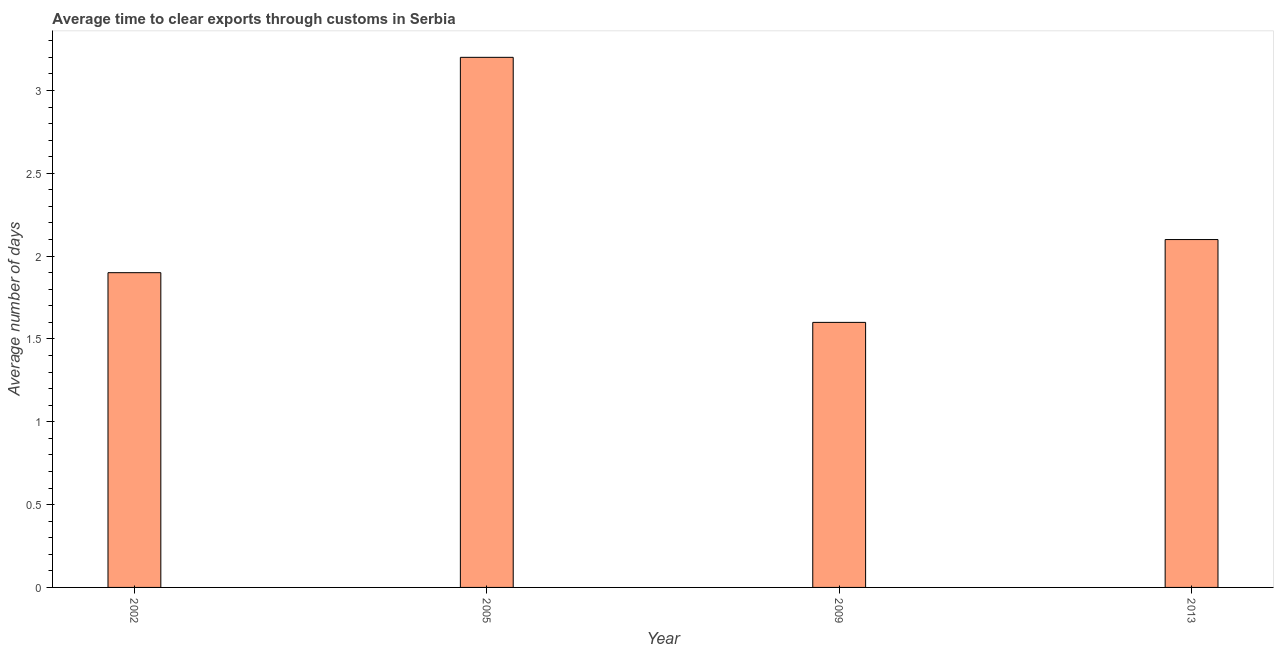Does the graph contain any zero values?
Give a very brief answer. No. Does the graph contain grids?
Provide a short and direct response. No. What is the title of the graph?
Your response must be concise. Average time to clear exports through customs in Serbia. What is the label or title of the Y-axis?
Keep it short and to the point. Average number of days. Across all years, what is the maximum time to clear exports through customs?
Provide a short and direct response. 3.2. Across all years, what is the minimum time to clear exports through customs?
Provide a short and direct response. 1.6. In which year was the time to clear exports through customs minimum?
Keep it short and to the point. 2009. What is the sum of the time to clear exports through customs?
Make the answer very short. 8.8. In how many years, is the time to clear exports through customs greater than 0.1 days?
Your answer should be very brief. 4. What is the ratio of the time to clear exports through customs in 2002 to that in 2005?
Your answer should be compact. 0.59. Is the time to clear exports through customs in 2002 less than that in 2013?
Make the answer very short. Yes. Is the sum of the time to clear exports through customs in 2005 and 2013 greater than the maximum time to clear exports through customs across all years?
Give a very brief answer. Yes. In how many years, is the time to clear exports through customs greater than the average time to clear exports through customs taken over all years?
Your response must be concise. 1. How many years are there in the graph?
Keep it short and to the point. 4. What is the difference between two consecutive major ticks on the Y-axis?
Your response must be concise. 0.5. What is the Average number of days of 2002?
Ensure brevity in your answer.  1.9. What is the Average number of days in 2005?
Ensure brevity in your answer.  3.2. What is the Average number of days of 2009?
Provide a short and direct response. 1.6. What is the difference between the Average number of days in 2002 and 2005?
Offer a very short reply. -1.3. What is the difference between the Average number of days in 2002 and 2009?
Provide a short and direct response. 0.3. What is the difference between the Average number of days in 2002 and 2013?
Offer a very short reply. -0.2. What is the difference between the Average number of days in 2005 and 2009?
Ensure brevity in your answer.  1.6. What is the difference between the Average number of days in 2009 and 2013?
Ensure brevity in your answer.  -0.5. What is the ratio of the Average number of days in 2002 to that in 2005?
Offer a terse response. 0.59. What is the ratio of the Average number of days in 2002 to that in 2009?
Keep it short and to the point. 1.19. What is the ratio of the Average number of days in 2002 to that in 2013?
Offer a terse response. 0.91. What is the ratio of the Average number of days in 2005 to that in 2013?
Your answer should be compact. 1.52. What is the ratio of the Average number of days in 2009 to that in 2013?
Your answer should be compact. 0.76. 